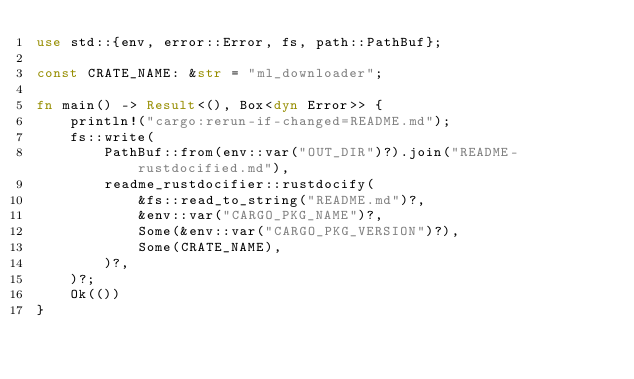<code> <loc_0><loc_0><loc_500><loc_500><_Rust_>use std::{env, error::Error, fs, path::PathBuf};

const CRATE_NAME: &str = "ml_downloader";

fn main() -> Result<(), Box<dyn Error>> {
    println!("cargo:rerun-if-changed=README.md");
    fs::write(
        PathBuf::from(env::var("OUT_DIR")?).join("README-rustdocified.md"),
        readme_rustdocifier::rustdocify(
            &fs::read_to_string("README.md")?,
            &env::var("CARGO_PKG_NAME")?,
            Some(&env::var("CARGO_PKG_VERSION")?),
            Some(CRATE_NAME),
        )?,
    )?;
    Ok(())
}
</code> 